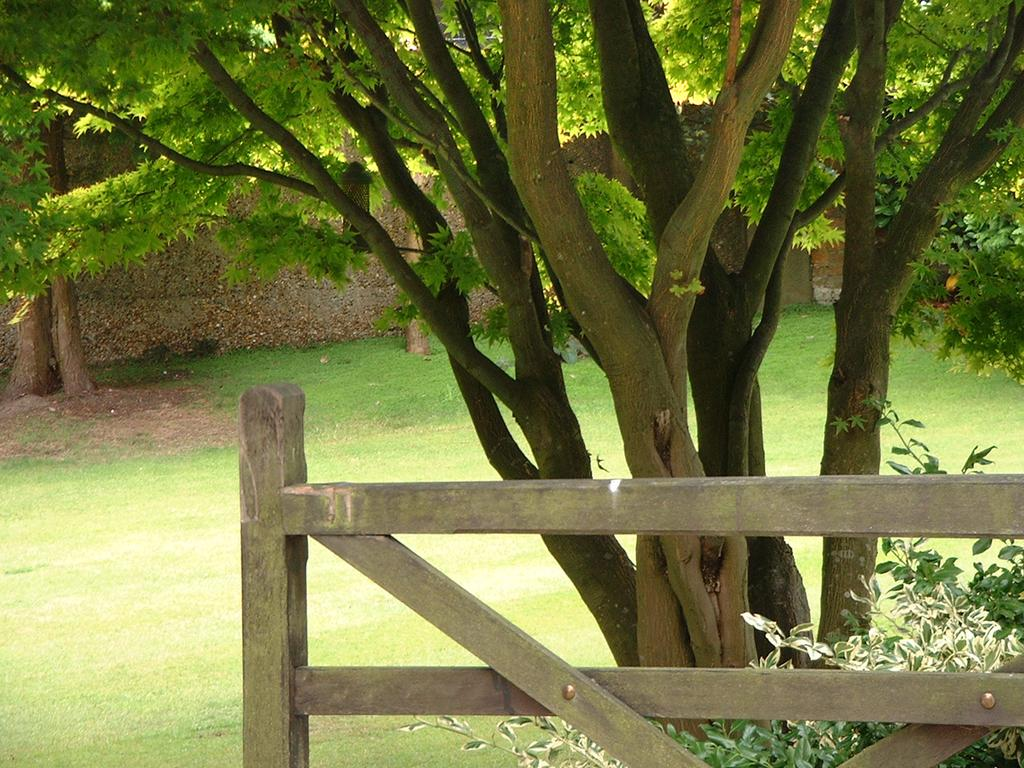What type of vegetation can be seen in the image? There are green color trees in the image. What material is the fencing made of in the image? The fencing in the image is made of wood. What structure is visible in the image? There is a wall in the image. What type of ground cover is present in the image? There is green grass in the image. Can you see a pig wearing a badge in the image? No, there is no pig or badge present in the image. 